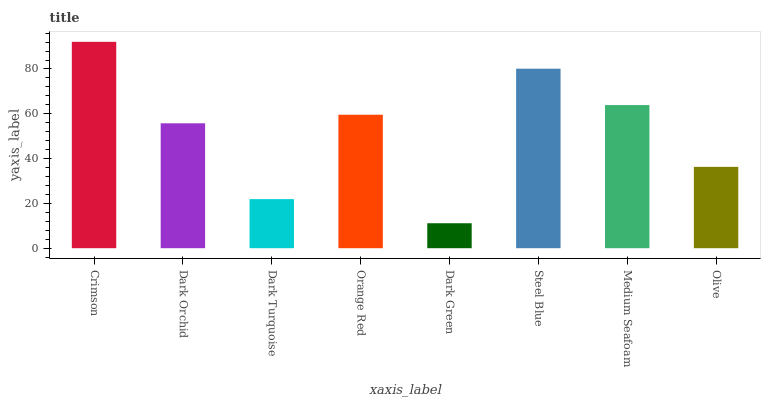Is Dark Green the minimum?
Answer yes or no. Yes. Is Crimson the maximum?
Answer yes or no. Yes. Is Dark Orchid the minimum?
Answer yes or no. No. Is Dark Orchid the maximum?
Answer yes or no. No. Is Crimson greater than Dark Orchid?
Answer yes or no. Yes. Is Dark Orchid less than Crimson?
Answer yes or no. Yes. Is Dark Orchid greater than Crimson?
Answer yes or no. No. Is Crimson less than Dark Orchid?
Answer yes or no. No. Is Orange Red the high median?
Answer yes or no. Yes. Is Dark Orchid the low median?
Answer yes or no. Yes. Is Dark Turquoise the high median?
Answer yes or no. No. Is Orange Red the low median?
Answer yes or no. No. 